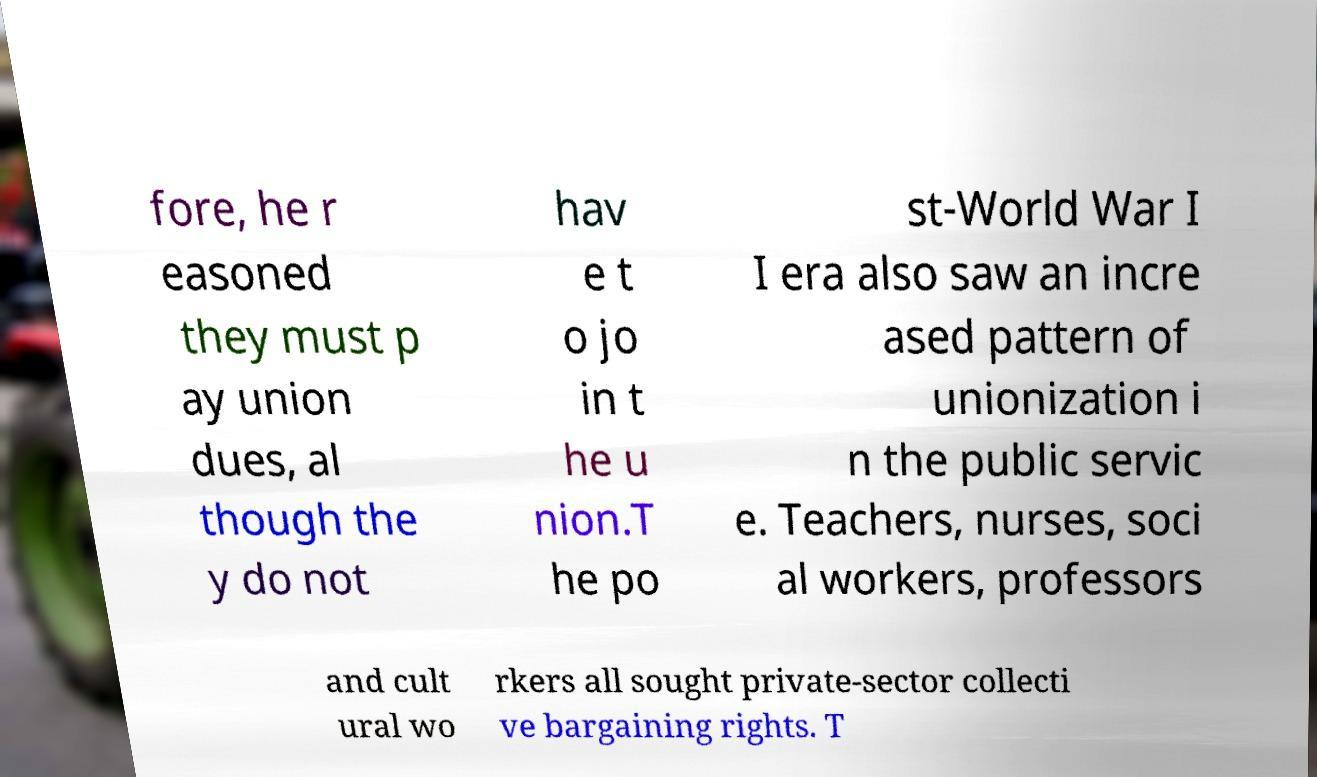What messages or text are displayed in this image? I need them in a readable, typed format. fore, he r easoned they must p ay union dues, al though the y do not hav e t o jo in t he u nion.T he po st-World War I I era also saw an incre ased pattern of unionization i n the public servic e. Teachers, nurses, soci al workers, professors and cult ural wo rkers all sought private-sector collecti ve bargaining rights. T 